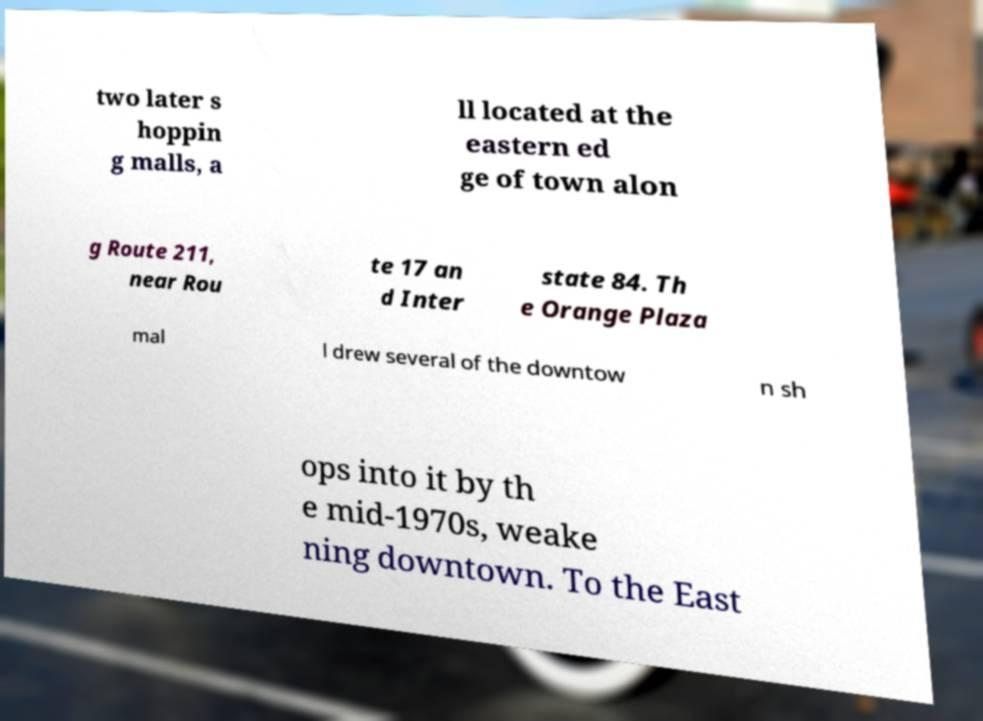I need the written content from this picture converted into text. Can you do that? two later s hoppin g malls, a ll located at the eastern ed ge of town alon g Route 211, near Rou te 17 an d Inter state 84. Th e Orange Plaza mal l drew several of the downtow n sh ops into it by th e mid-1970s, weake ning downtown. To the East 